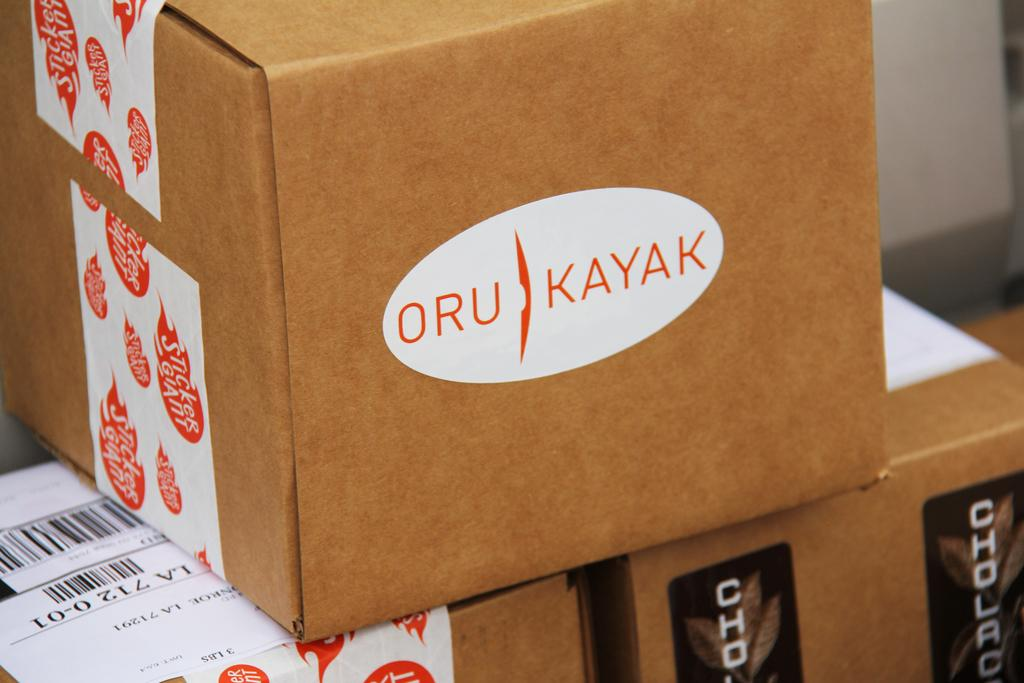<image>
Describe the image concisely. Cardboard boxes are stacked together and the top one has a sticker that says Oru Kayak. 